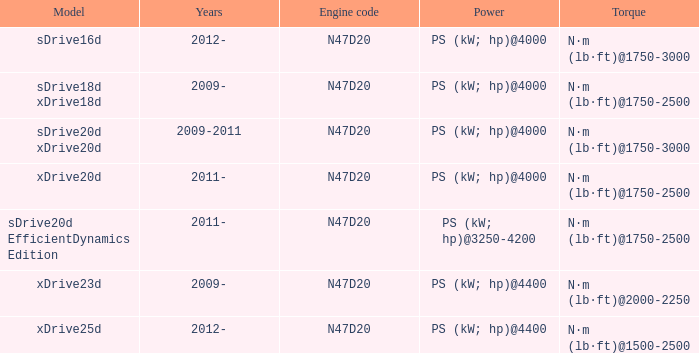What is the engine code of the xdrive23d model? N47D20. 